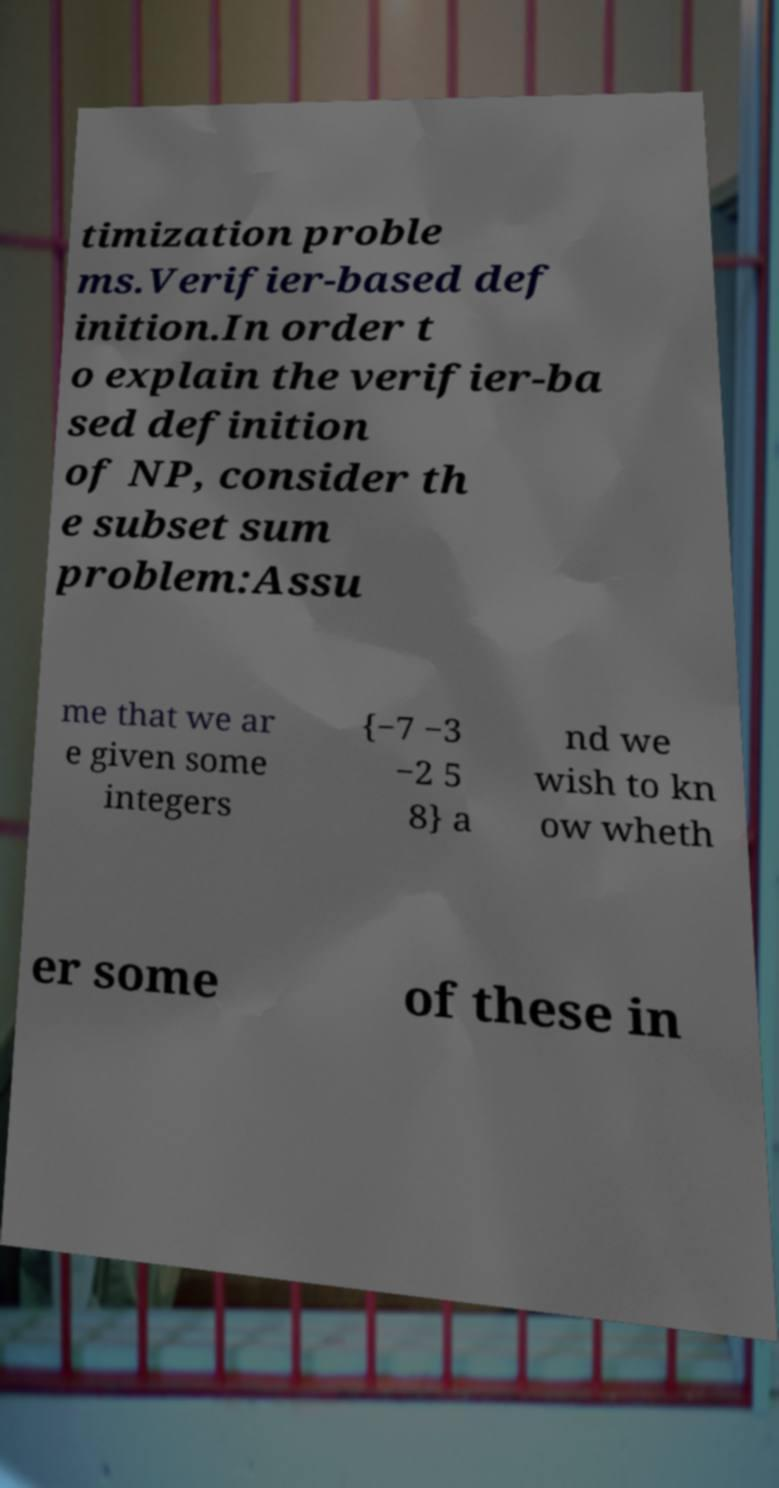Can you read and provide the text displayed in the image?This photo seems to have some interesting text. Can you extract and type it out for me? timization proble ms.Verifier-based def inition.In order t o explain the verifier-ba sed definition of NP, consider th e subset sum problem:Assu me that we ar e given some integers {−7 −3 −2 5 8} a nd we wish to kn ow wheth er some of these in 